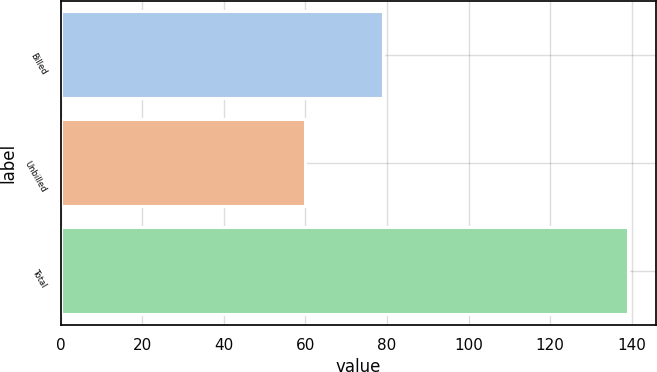<chart> <loc_0><loc_0><loc_500><loc_500><bar_chart><fcel>Billed<fcel>Unbilled<fcel>Total<nl><fcel>79<fcel>60<fcel>139<nl></chart> 